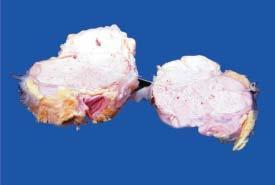what are there in the circumscribed nodular areas?
Answer the question using a single word or phrase. Areas of necrosis 